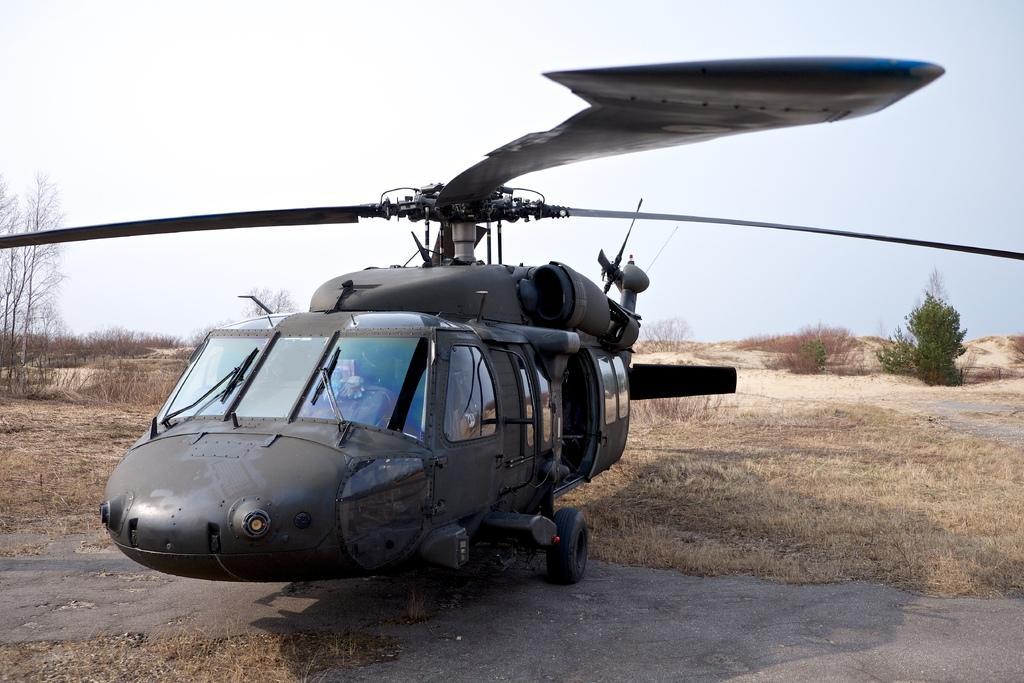Describe this image in one or two sentences. In the center of the image, we can see a helicopter on the ground and in the background, there are trees. At the top, there is sky. 